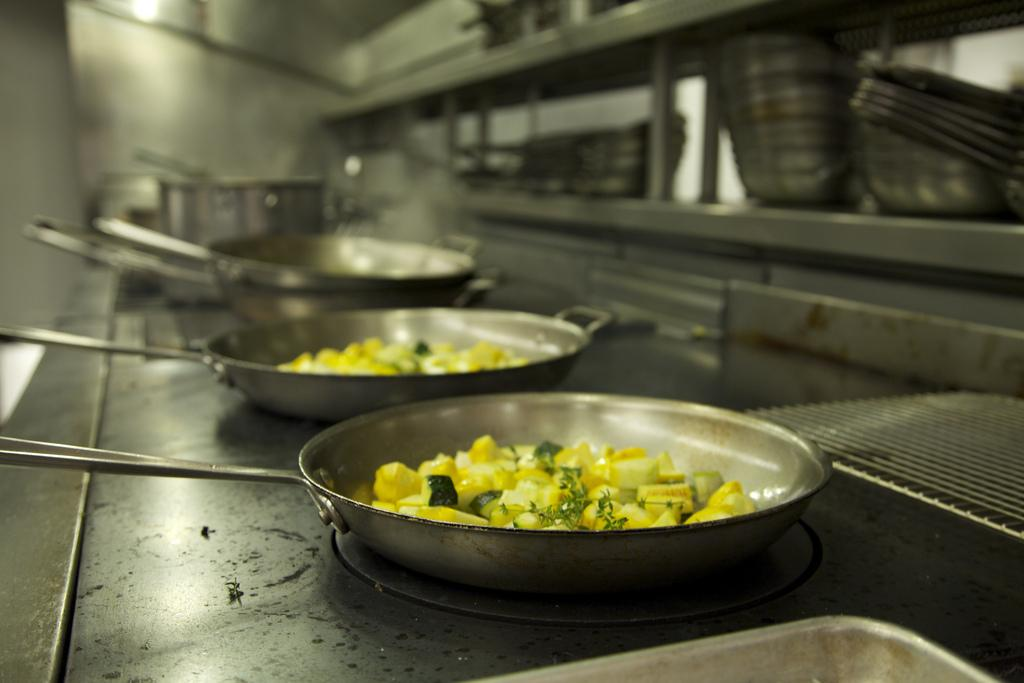What is being cooked in the pan on the stove? The food items in the pan on the stove are being cooked. Where are the utensils located in relation to the stove? The utensils are on the shelf in front of the stove. What can be seen at the top of the image? There is a lamp at the top of the image. What type of harmony is being played in the background of the image? There is no music or harmony present in the image. Can you see a hook hanging from the lamp in the image? There is no hook visible on the lamp in the image. 